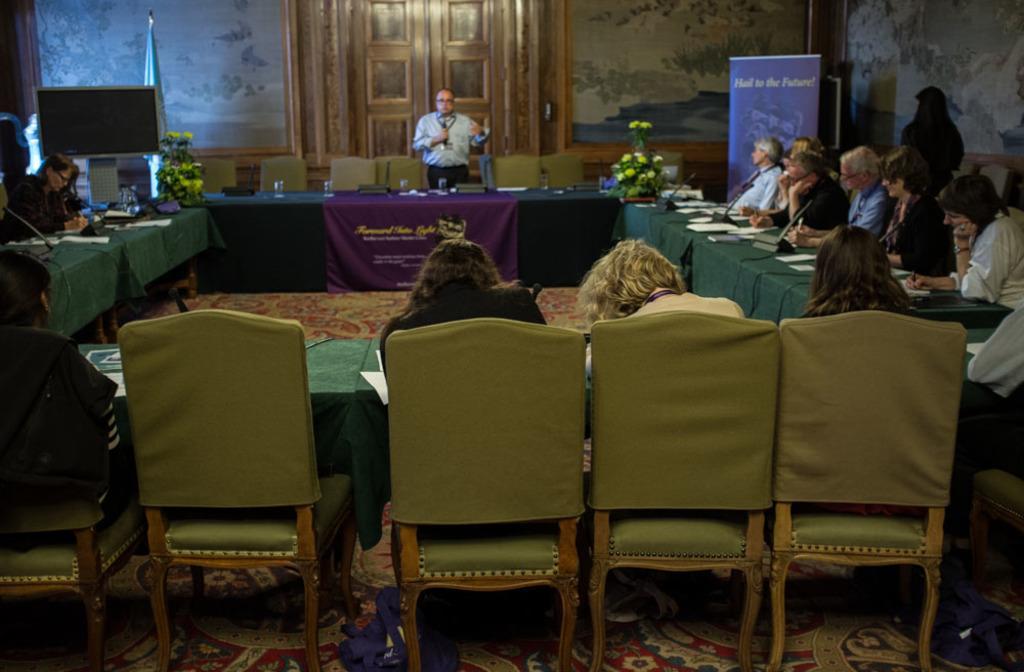Please provide a concise description of this image. These persons are sitting on a chair. On this table there is a banner, papers and mic. Far there is a banner. On this table there is a bouquet. This person is standing and holding a mic. This is door. 